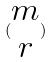Convert formula to latex. <formula><loc_0><loc_0><loc_500><loc_500>( \begin{matrix} m \\ r \end{matrix} )</formula> 